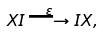Convert formula to latex. <formula><loc_0><loc_0><loc_500><loc_500>X I \stackrel { \varepsilon } { \longrightarrow } I X ,</formula> 